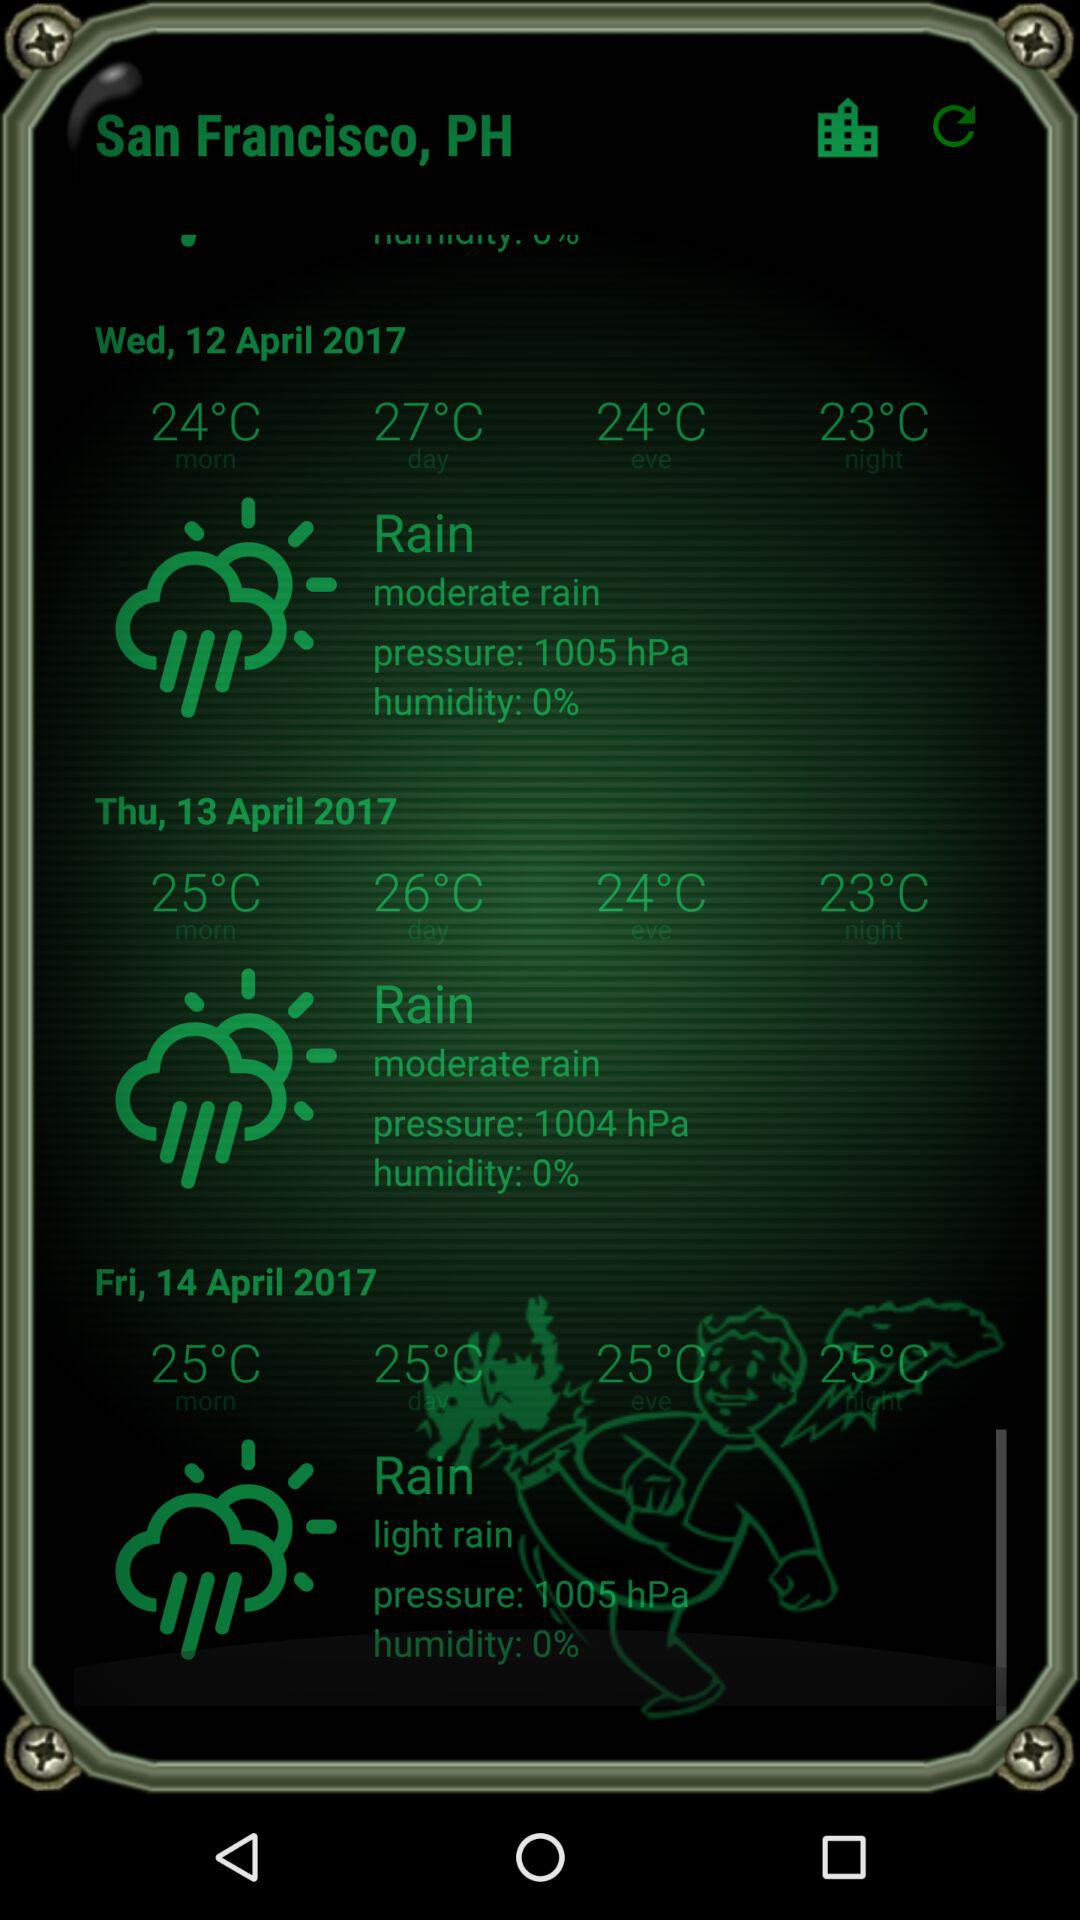What is the air pressure for Friday? The air pressure for Friday is 1005 hPa. 